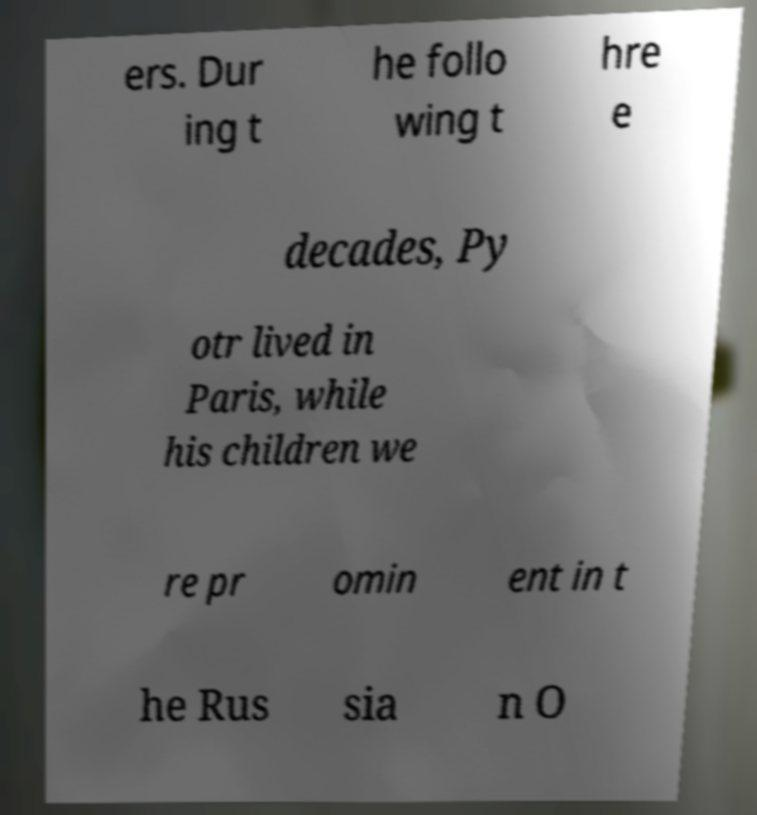Can you accurately transcribe the text from the provided image for me? ers. Dur ing t he follo wing t hre e decades, Py otr lived in Paris, while his children we re pr omin ent in t he Rus sia n O 